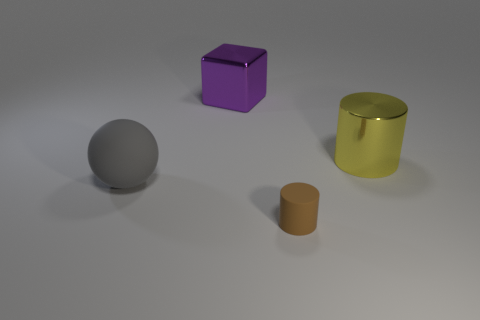Are there any gray things that have the same material as the big sphere?
Your answer should be very brief. No. Does the large sphere have the same material as the tiny brown cylinder?
Ensure brevity in your answer.  Yes. There is a cylinder that is the same size as the sphere; what color is it?
Offer a very short reply. Yellow. What number of other things are the same shape as the tiny brown rubber object?
Provide a succinct answer. 1. Does the purple thing have the same size as the rubber object to the right of the large gray sphere?
Your answer should be compact. No. What number of things are tiny brown balls or metal cubes?
Your answer should be compact. 1. How many other objects are the same size as the yellow shiny thing?
Offer a very short reply. 2. Does the tiny cylinder have the same color as the metal thing that is to the left of the large metallic cylinder?
Offer a very short reply. No. How many spheres are purple things or large shiny objects?
Your answer should be very brief. 0. Are there any other things that have the same color as the sphere?
Make the answer very short. No. 